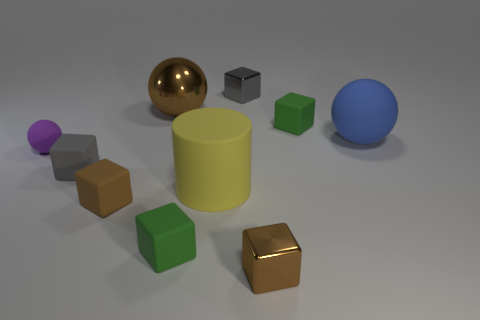How many objects are either cyan blocks or large blue rubber things?
Ensure brevity in your answer.  1. How big is the rubber cylinder?
Provide a succinct answer. Large. Are there fewer tiny purple balls than green metal objects?
Provide a succinct answer. No. What number of large rubber things are the same color as the large matte ball?
Your response must be concise. 0. There is a big matte thing that is in front of the large blue matte sphere; is it the same color as the big shiny thing?
Offer a very short reply. No. There is a gray object in front of the gray metal thing; what is its shape?
Keep it short and to the point. Cube. Is there a small green cube behind the shiny thing in front of the big brown metallic sphere?
Your response must be concise. Yes. What number of big gray objects are made of the same material as the large yellow cylinder?
Your response must be concise. 0. There is a brown thing left of the brown ball on the right side of the small gray block that is in front of the small purple sphere; what is its size?
Ensure brevity in your answer.  Small. What number of big yellow cylinders are left of the yellow rubber cylinder?
Offer a terse response. 0. 